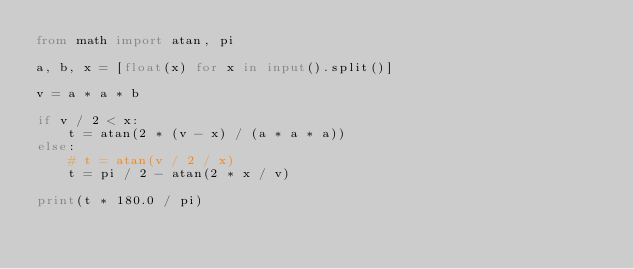<code> <loc_0><loc_0><loc_500><loc_500><_Python_>from math import atan, pi

a, b, x = [float(x) for x in input().split()]

v = a * a * b

if v / 2 < x:
    t = atan(2 * (v - x) / (a * a * a))
else:
    # t = atan(v / 2 / x)
    t = pi / 2 - atan(2 * x / v)

print(t * 180.0 / pi)
</code> 